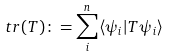<formula> <loc_0><loc_0><loc_500><loc_500>t r ( T ) \colon = \sum _ { i } ^ { n } \langle \psi _ { i } | T \psi _ { i } \rangle</formula> 